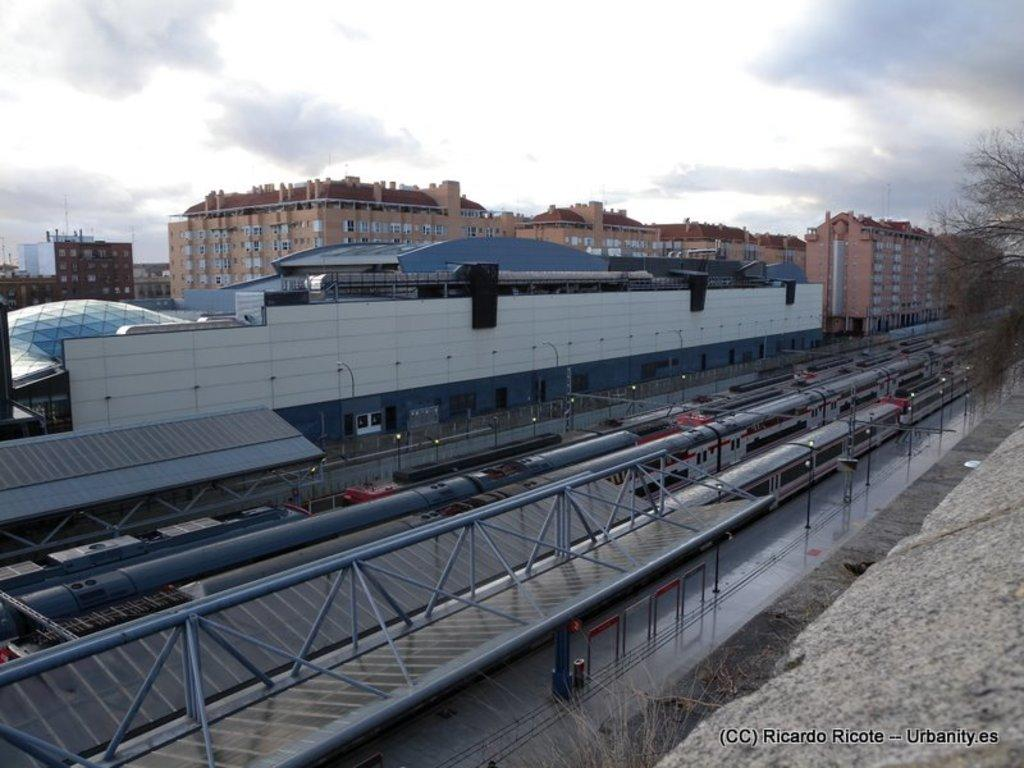What type of vehicles can be seen in the image? There are trains in the image. What is located beside the trains? There is a platform beside the trains. What structure is visible above the trains? There is a roof visible in the image. What type of infrastructure is present in the image? Electric poles are present in the image. What type of barrier is present in the image? There is a fence in the image. What type of natural elements are visible in the image? Trees are visible in the image. What type of structures can be seen in the background of the image? There are buildings in the background of the image. What part of the natural environment is visible in the background of the image? The sky is visible in the background of the image. What type of lamp is hanging from the train in the image? There is no lamp hanging from the train in the image. 